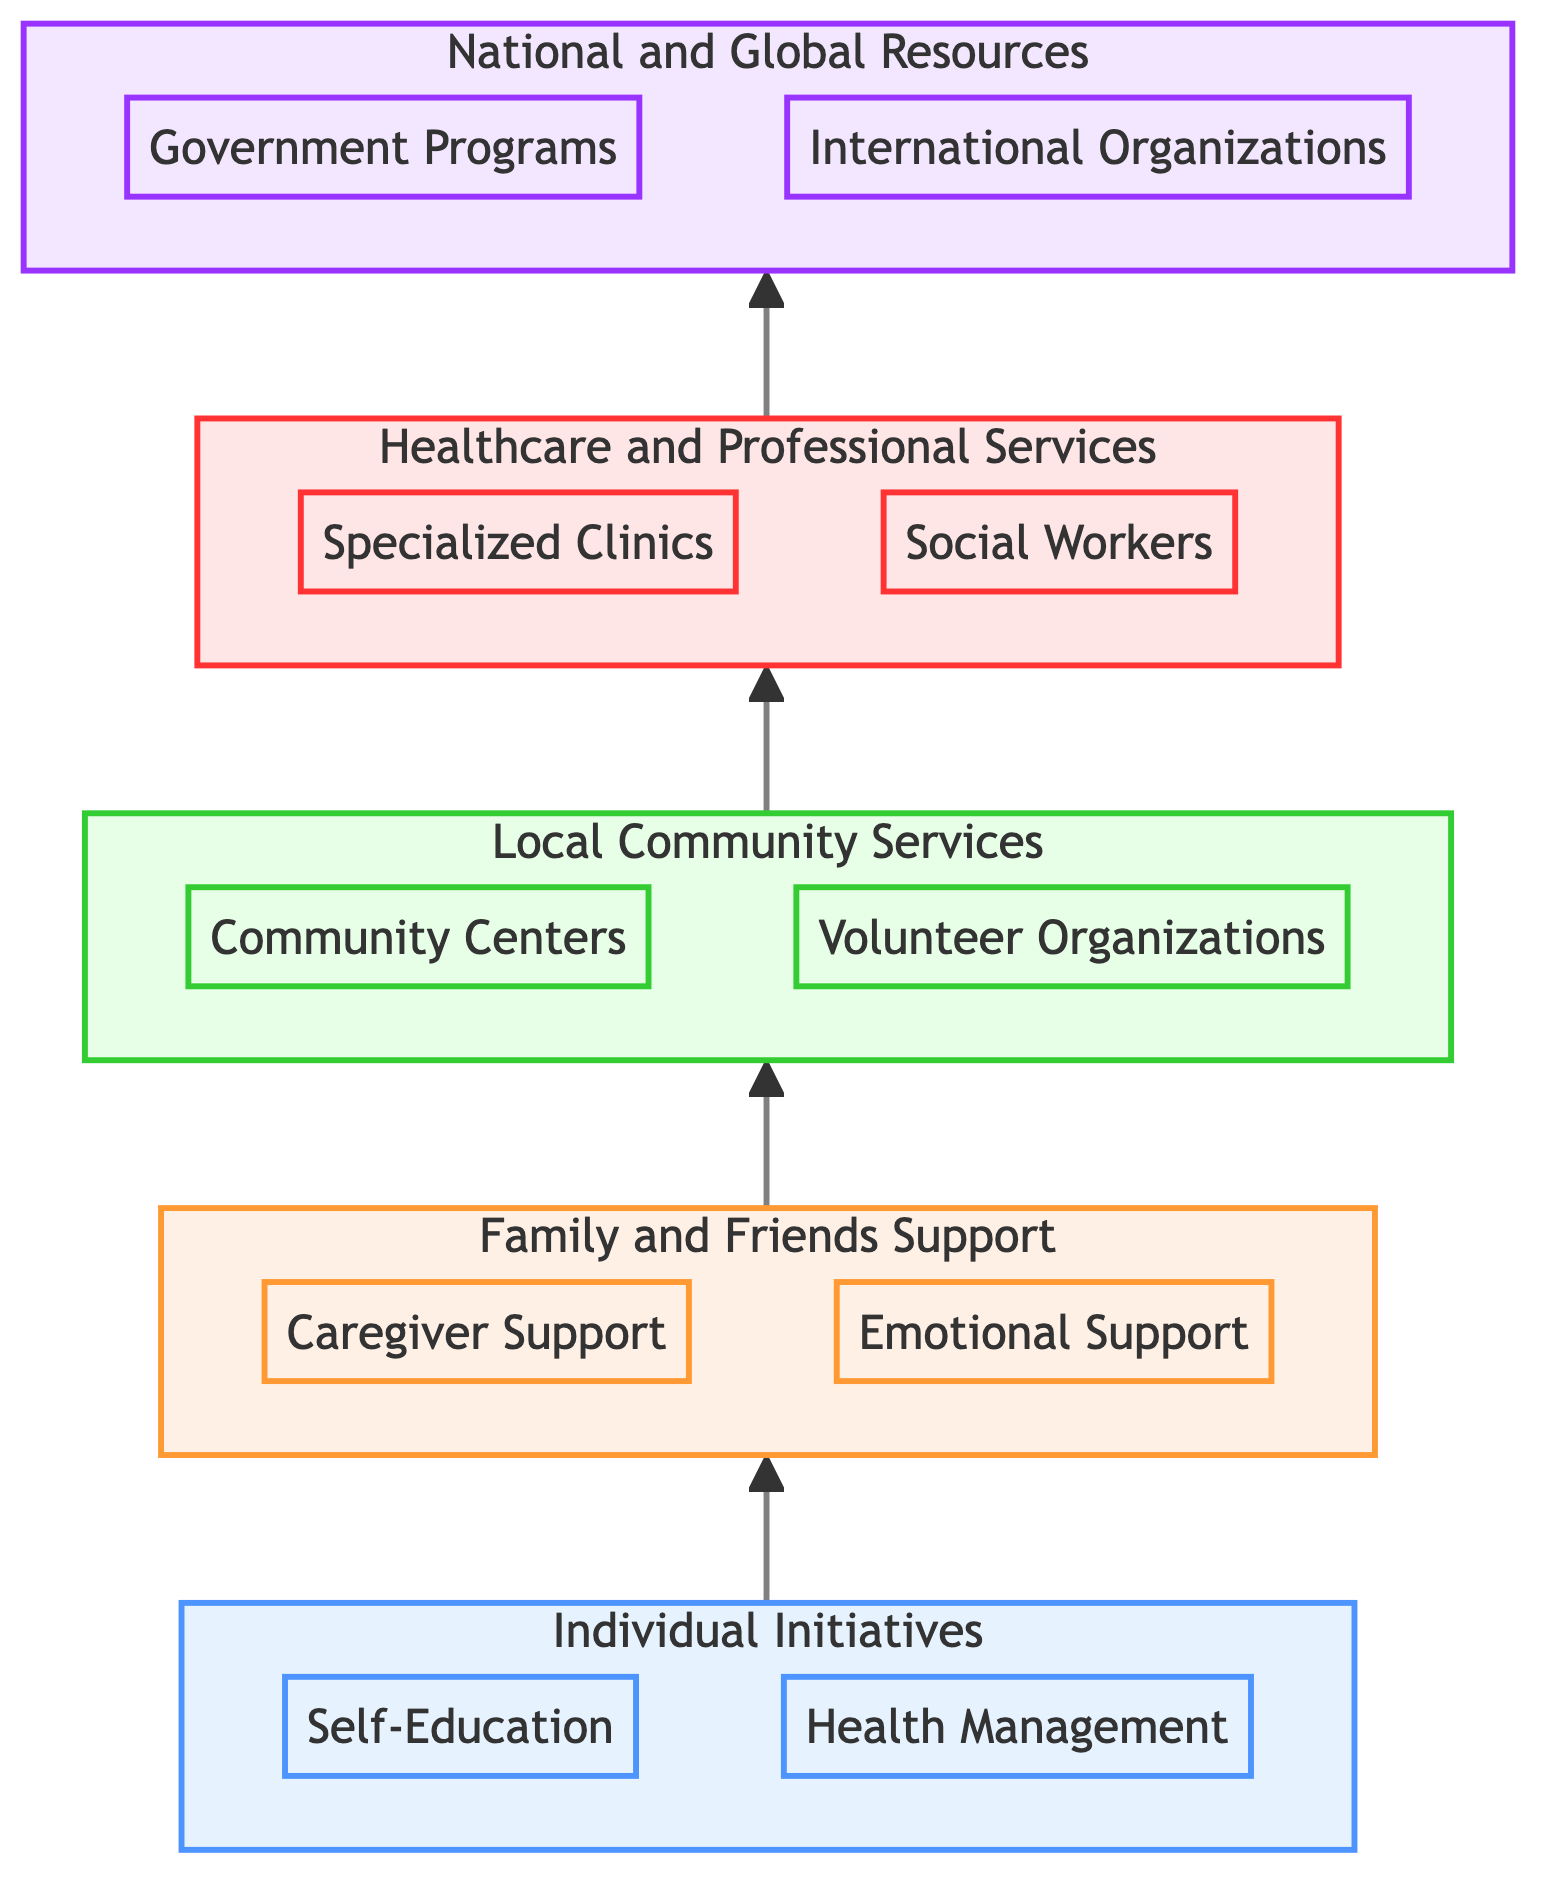What is the top-level category in the diagram? The top-level category is identified by the highest node in the flowchart, which is the last level labeled "National and Global Resources."
Answer: National and Global Resources How many components are there in "Local Community Services"? To determine this, we can count the components listed under the "Local Community Services" level, which includes two components: "Community Centers" and "Volunteer Organizations."
Answer: 2 Which component provides emotional and mental support? The component that specifically provides emotional and mental support is labeled "Emotional Support," which is included in the "Family and Friends Support" category.
Answer: Emotional Support What level comes directly after "Individual Initiatives"? The flowchart shows a direct upward arrow linking "Individual Initiatives" to "Family and Friends Support," indicating that "Family and Friends Support" follows "Individual Initiatives."
Answer: Family and Friends Support What type of support does the "Volunteer Organizations" component offer? The diagram indicates that the "Volunteer Organizations" offer support and information related to dementia care, which aligns with their function as community resource providers.
Answer: Support and information What is the relationship between "Healthcare and Professional Services" and "National and Global Resources"? The relationship is sequential, where "Healthcare and Professional Services" provides a foundation for accessing "National and Global Resources," reflecting how local support leads to broader resources.
Answer: Sequential How many levels are there in total in the diagram? To find the total number of levels, we can count each distinct level from "Individual Initiatives" to "National and Global Resources," which results in five levels.
Answer: 5 Which component is aimed at assisting with daily activities? The component aimed at assisting with daily activities within the diagram is "Caregiver Support," found in the "Family and Friends Support" category.
Answer: Caregiver Support What kind of services do "Specialized Clinics" offer? "Specialized Clinics" provide healthcare services that specifically target the needs of individuals with dementia, focusing on care and treatment.
Answer: Dementia care and treatment What is the lowest-level category in the diagram? The lowest-level category is the first element that appears at the bottom of the flow, which indicates fundamental individual efforts. This category is labeled "Individual Initiatives."
Answer: Individual Initiatives 